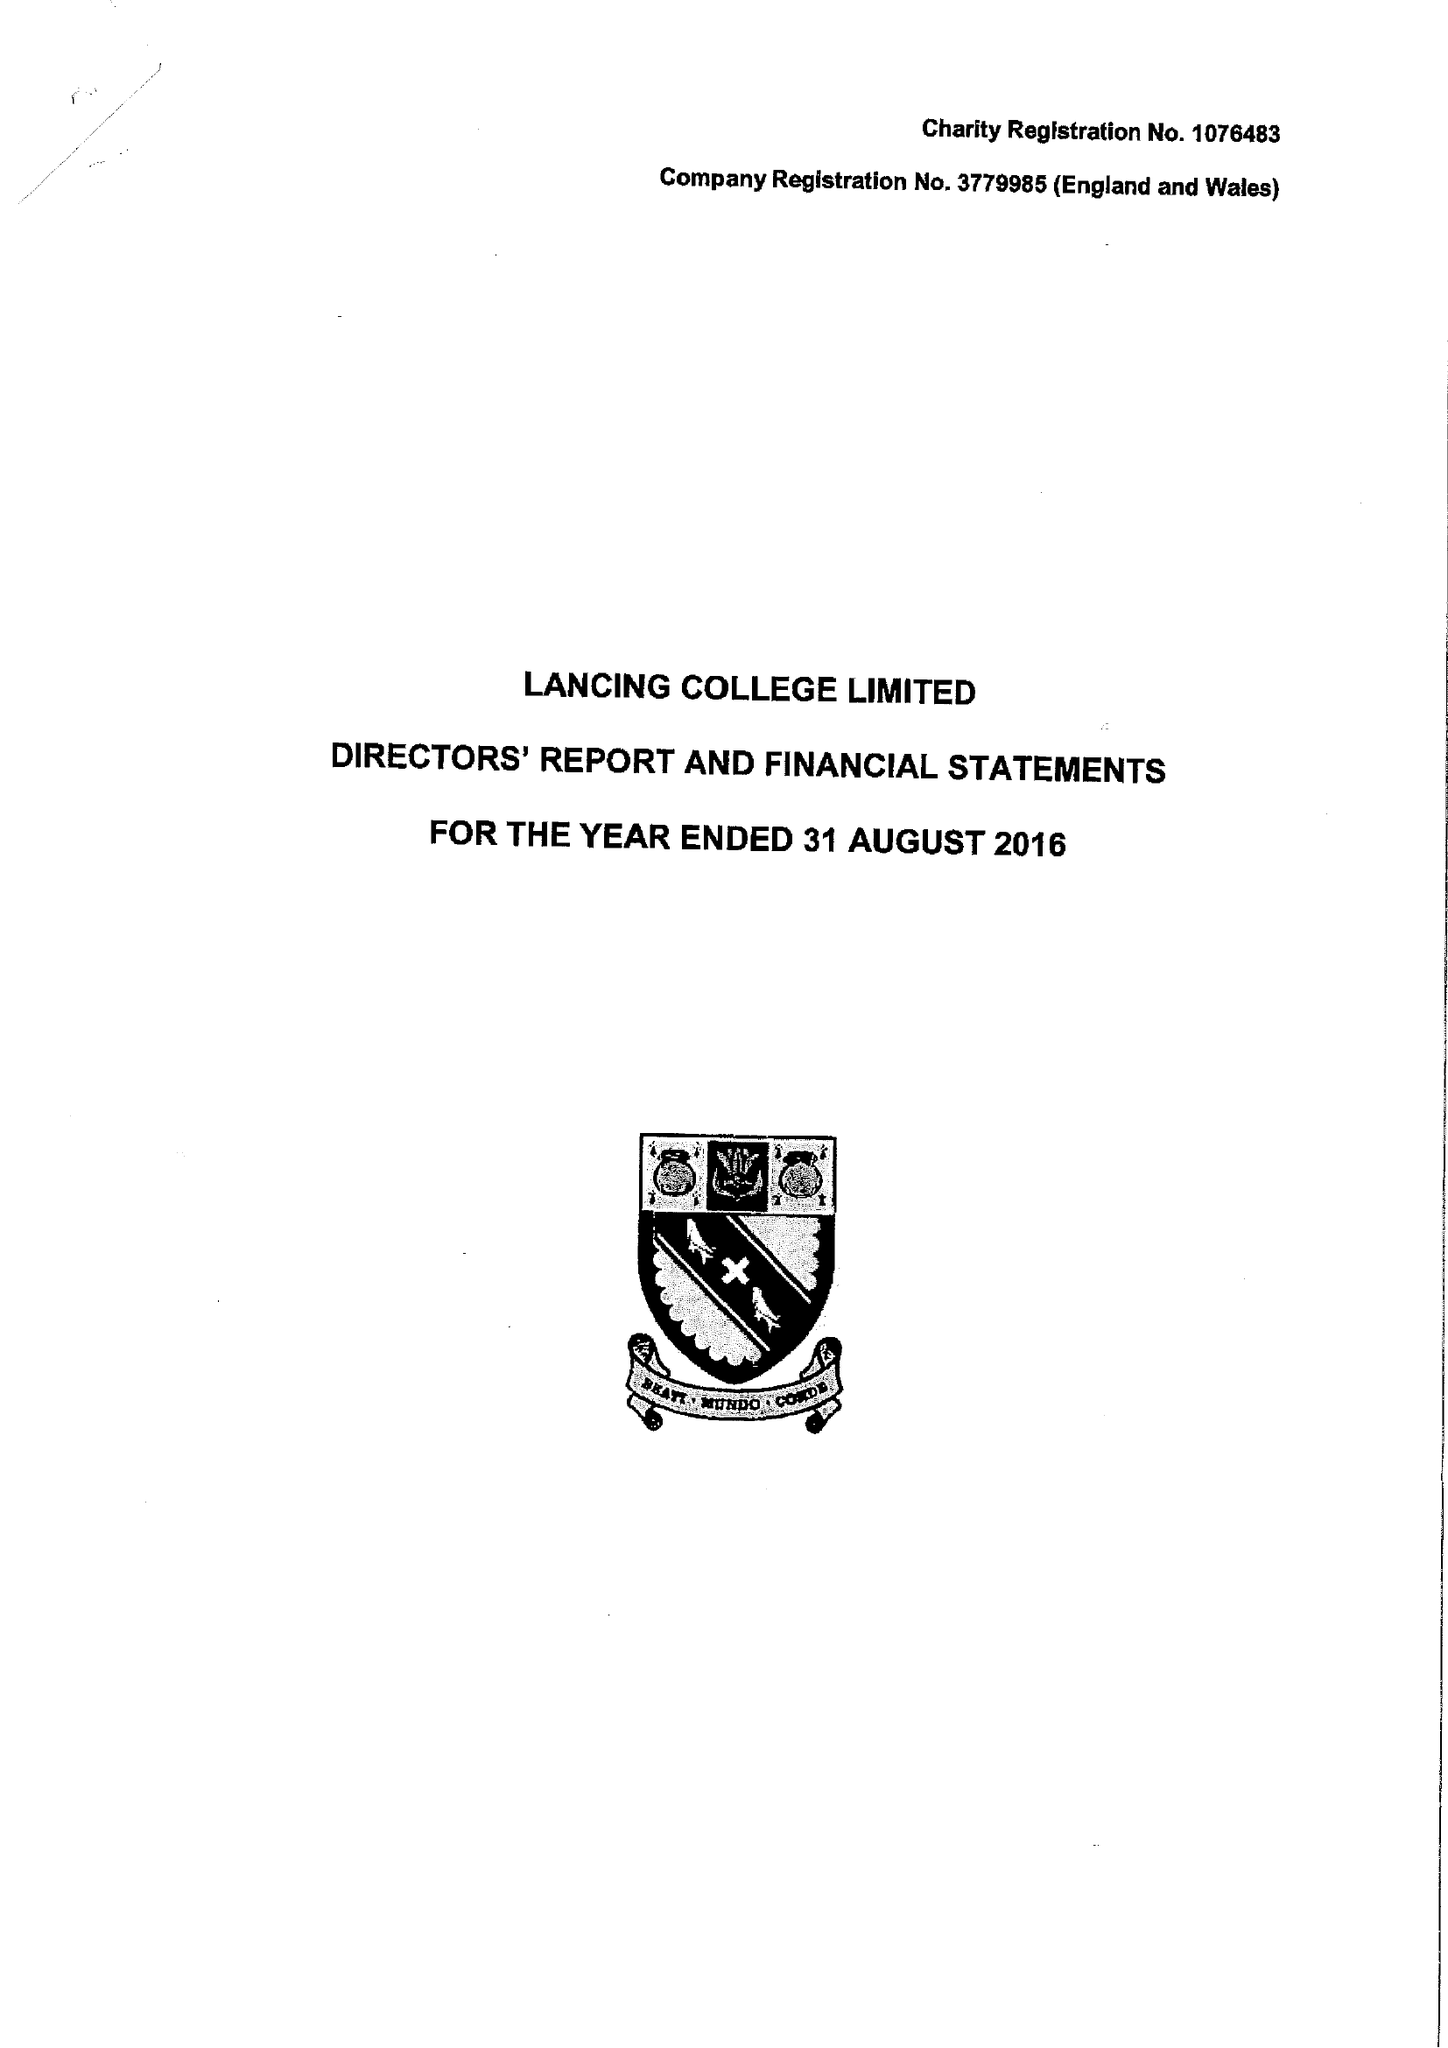What is the value for the spending_annually_in_british_pounds?
Answer the question using a single word or phrase. 19244853.00 